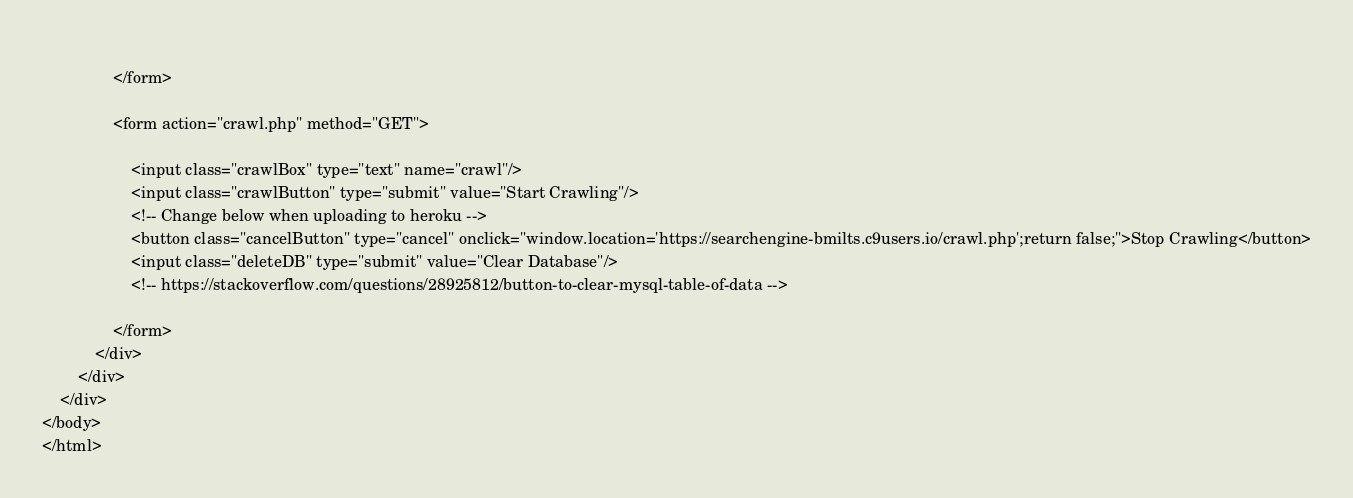<code> <loc_0><loc_0><loc_500><loc_500><_PHP_>                
                </form>
                
                <form action="crawl.php" method="GET">
                    
                    <input class="crawlBox" type="text" name="crawl"/>
                    <input class="crawlButton" type="submit" value="Start Crawling"/>
                    <!-- Change below when uploading to heroku -->
                    <button class="cancelButton" type="cancel" onclick="window.location='https://searchengine-bmilts.c9users.io/crawl.php';return false;">Stop Crawling</button>
                    <input class="deleteDB" type="submit" value="Clear Database"/>
                    <!-- https://stackoverflow.com/questions/28925812/button-to-clear-mysql-table-of-data -->

                </form>
            </div>
        </div>
    </div>
</body>
</html></code> 